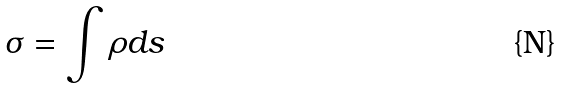<formula> <loc_0><loc_0><loc_500><loc_500>\sigma = \int \rho d s</formula> 